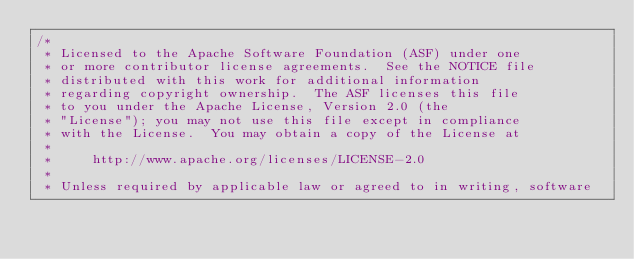Convert code to text. <code><loc_0><loc_0><loc_500><loc_500><_Java_>/*
 * Licensed to the Apache Software Foundation (ASF) under one
 * or more contributor license agreements.  See the NOTICE file
 * distributed with this work for additional information
 * regarding copyright ownership.  The ASF licenses this file
 * to you under the Apache License, Version 2.0 (the
 * "License"); you may not use this file except in compliance
 * with the License.  You may obtain a copy of the License at
 *
 *     http://www.apache.org/licenses/LICENSE-2.0
 *
 * Unless required by applicable law or agreed to in writing, software</code> 